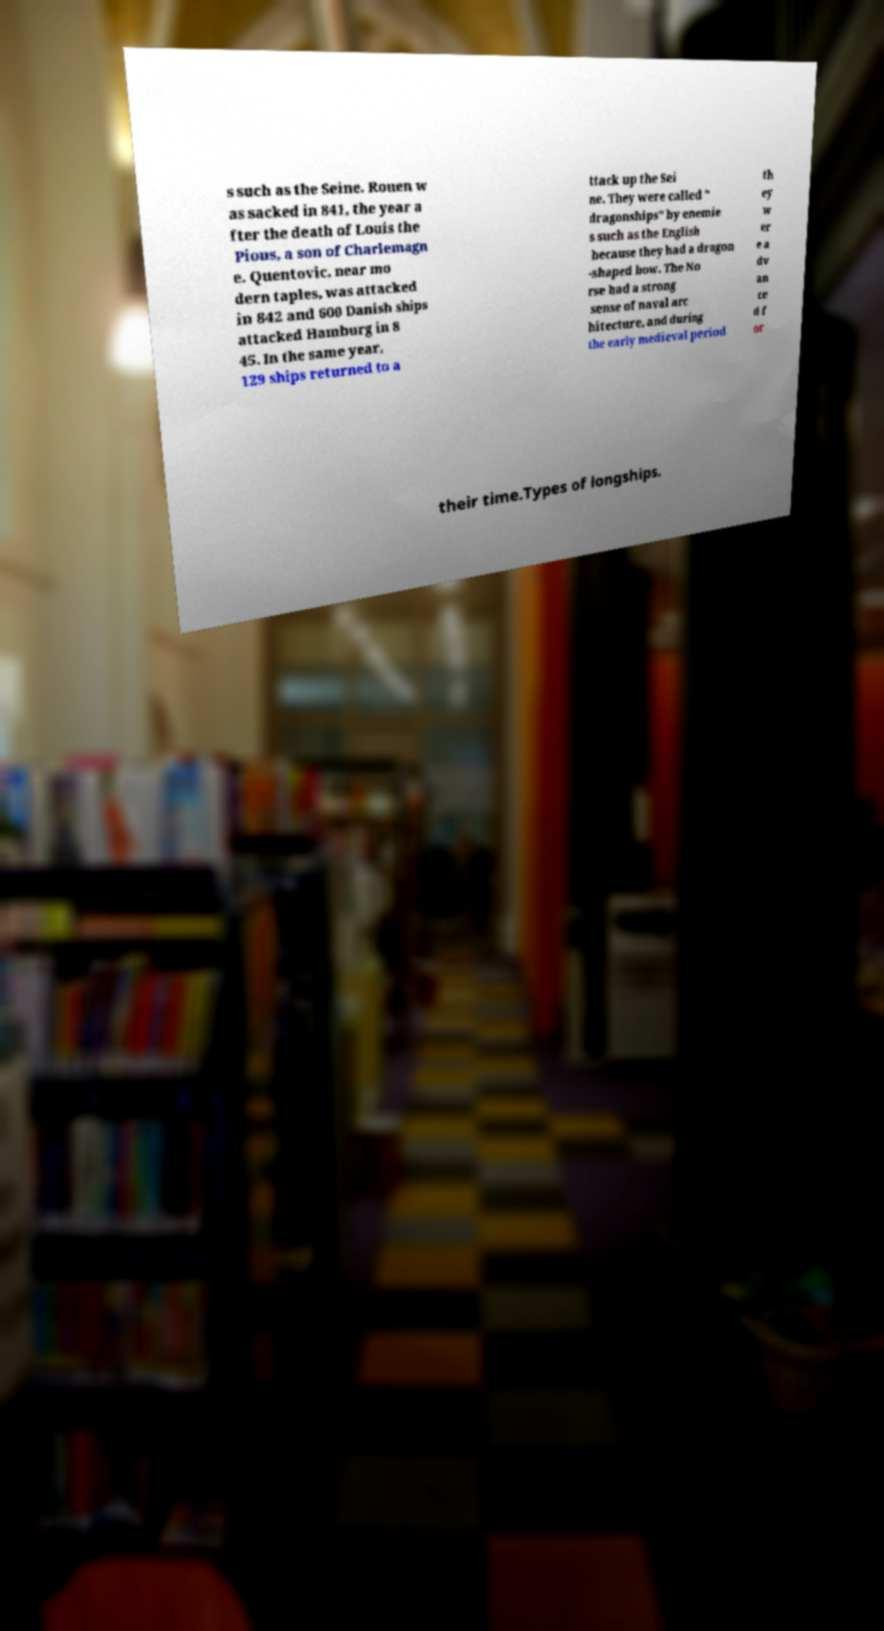Can you read and provide the text displayed in the image?This photo seems to have some interesting text. Can you extract and type it out for me? s such as the Seine. Rouen w as sacked in 841, the year a fter the death of Louis the Pious, a son of Charlemagn e. Quentovic, near mo dern taples, was attacked in 842 and 600 Danish ships attacked Hamburg in 8 45. In the same year, 129 ships returned to a ttack up the Sei ne. They were called " dragonships" by enemie s such as the English because they had a dragon -shaped bow. The No rse had a strong sense of naval arc hitecture, and during the early medieval period th ey w er e a dv an ce d f or their time.Types of longships. 